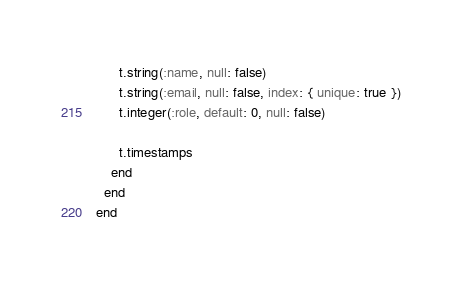<code> <loc_0><loc_0><loc_500><loc_500><_Ruby_>      t.string(:name, null: false)
      t.string(:email, null: false, index: { unique: true })
      t.integer(:role, default: 0, null: false)

      t.timestamps
    end
  end
end
</code> 